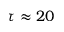Convert formula to latex. <formula><loc_0><loc_0><loc_500><loc_500>\tau \approx 2 0</formula> 